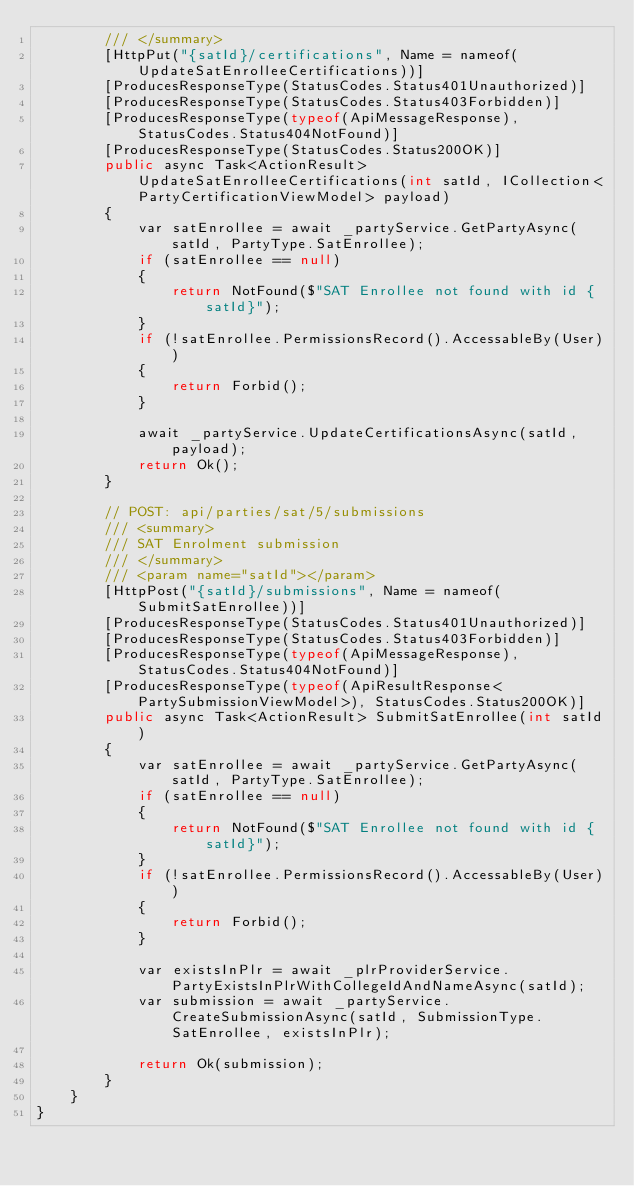Convert code to text. <code><loc_0><loc_0><loc_500><loc_500><_C#_>        /// </summary>
        [HttpPut("{satId}/certifications", Name = nameof(UpdateSatEnrolleeCertifications))]
        [ProducesResponseType(StatusCodes.Status401Unauthorized)]
        [ProducesResponseType(StatusCodes.Status403Forbidden)]
        [ProducesResponseType(typeof(ApiMessageResponse), StatusCodes.Status404NotFound)]
        [ProducesResponseType(StatusCodes.Status200OK)]
        public async Task<ActionResult> UpdateSatEnrolleeCertifications(int satId, ICollection<PartyCertificationViewModel> payload)
        {
            var satEnrollee = await _partyService.GetPartyAsync(satId, PartyType.SatEnrollee);
            if (satEnrollee == null)
            {
                return NotFound($"SAT Enrollee not found with id {satId}");
            }
            if (!satEnrollee.PermissionsRecord().AccessableBy(User))
            {
                return Forbid();
            }

            await _partyService.UpdateCertificationsAsync(satId, payload);
            return Ok();
        }

        // POST: api/parties/sat/5/submissions
        /// <summary>
        /// SAT Enrolment submission
        /// </summary>
        /// <param name="satId"></param>
        [HttpPost("{satId}/submissions", Name = nameof(SubmitSatEnrollee))]
        [ProducesResponseType(StatusCodes.Status401Unauthorized)]
        [ProducesResponseType(StatusCodes.Status403Forbidden)]
        [ProducesResponseType(typeof(ApiMessageResponse), StatusCodes.Status404NotFound)]
        [ProducesResponseType(typeof(ApiResultResponse<PartySubmissionViewModel>), StatusCodes.Status200OK)]
        public async Task<ActionResult> SubmitSatEnrollee(int satId)
        {
            var satEnrollee = await _partyService.GetPartyAsync(satId, PartyType.SatEnrollee);
            if (satEnrollee == null)
            {
                return NotFound($"SAT Enrollee not found with id {satId}");
            }
            if (!satEnrollee.PermissionsRecord().AccessableBy(User))
            {
                return Forbid();
            }

            var existsInPlr = await _plrProviderService.PartyExistsInPlrWithCollegeIdAndNameAsync(satId);
            var submission = await _partyService.CreateSubmissionAsync(satId, SubmissionType.SatEnrollee, existsInPlr);

            return Ok(submission);
        }
    }
}
</code> 